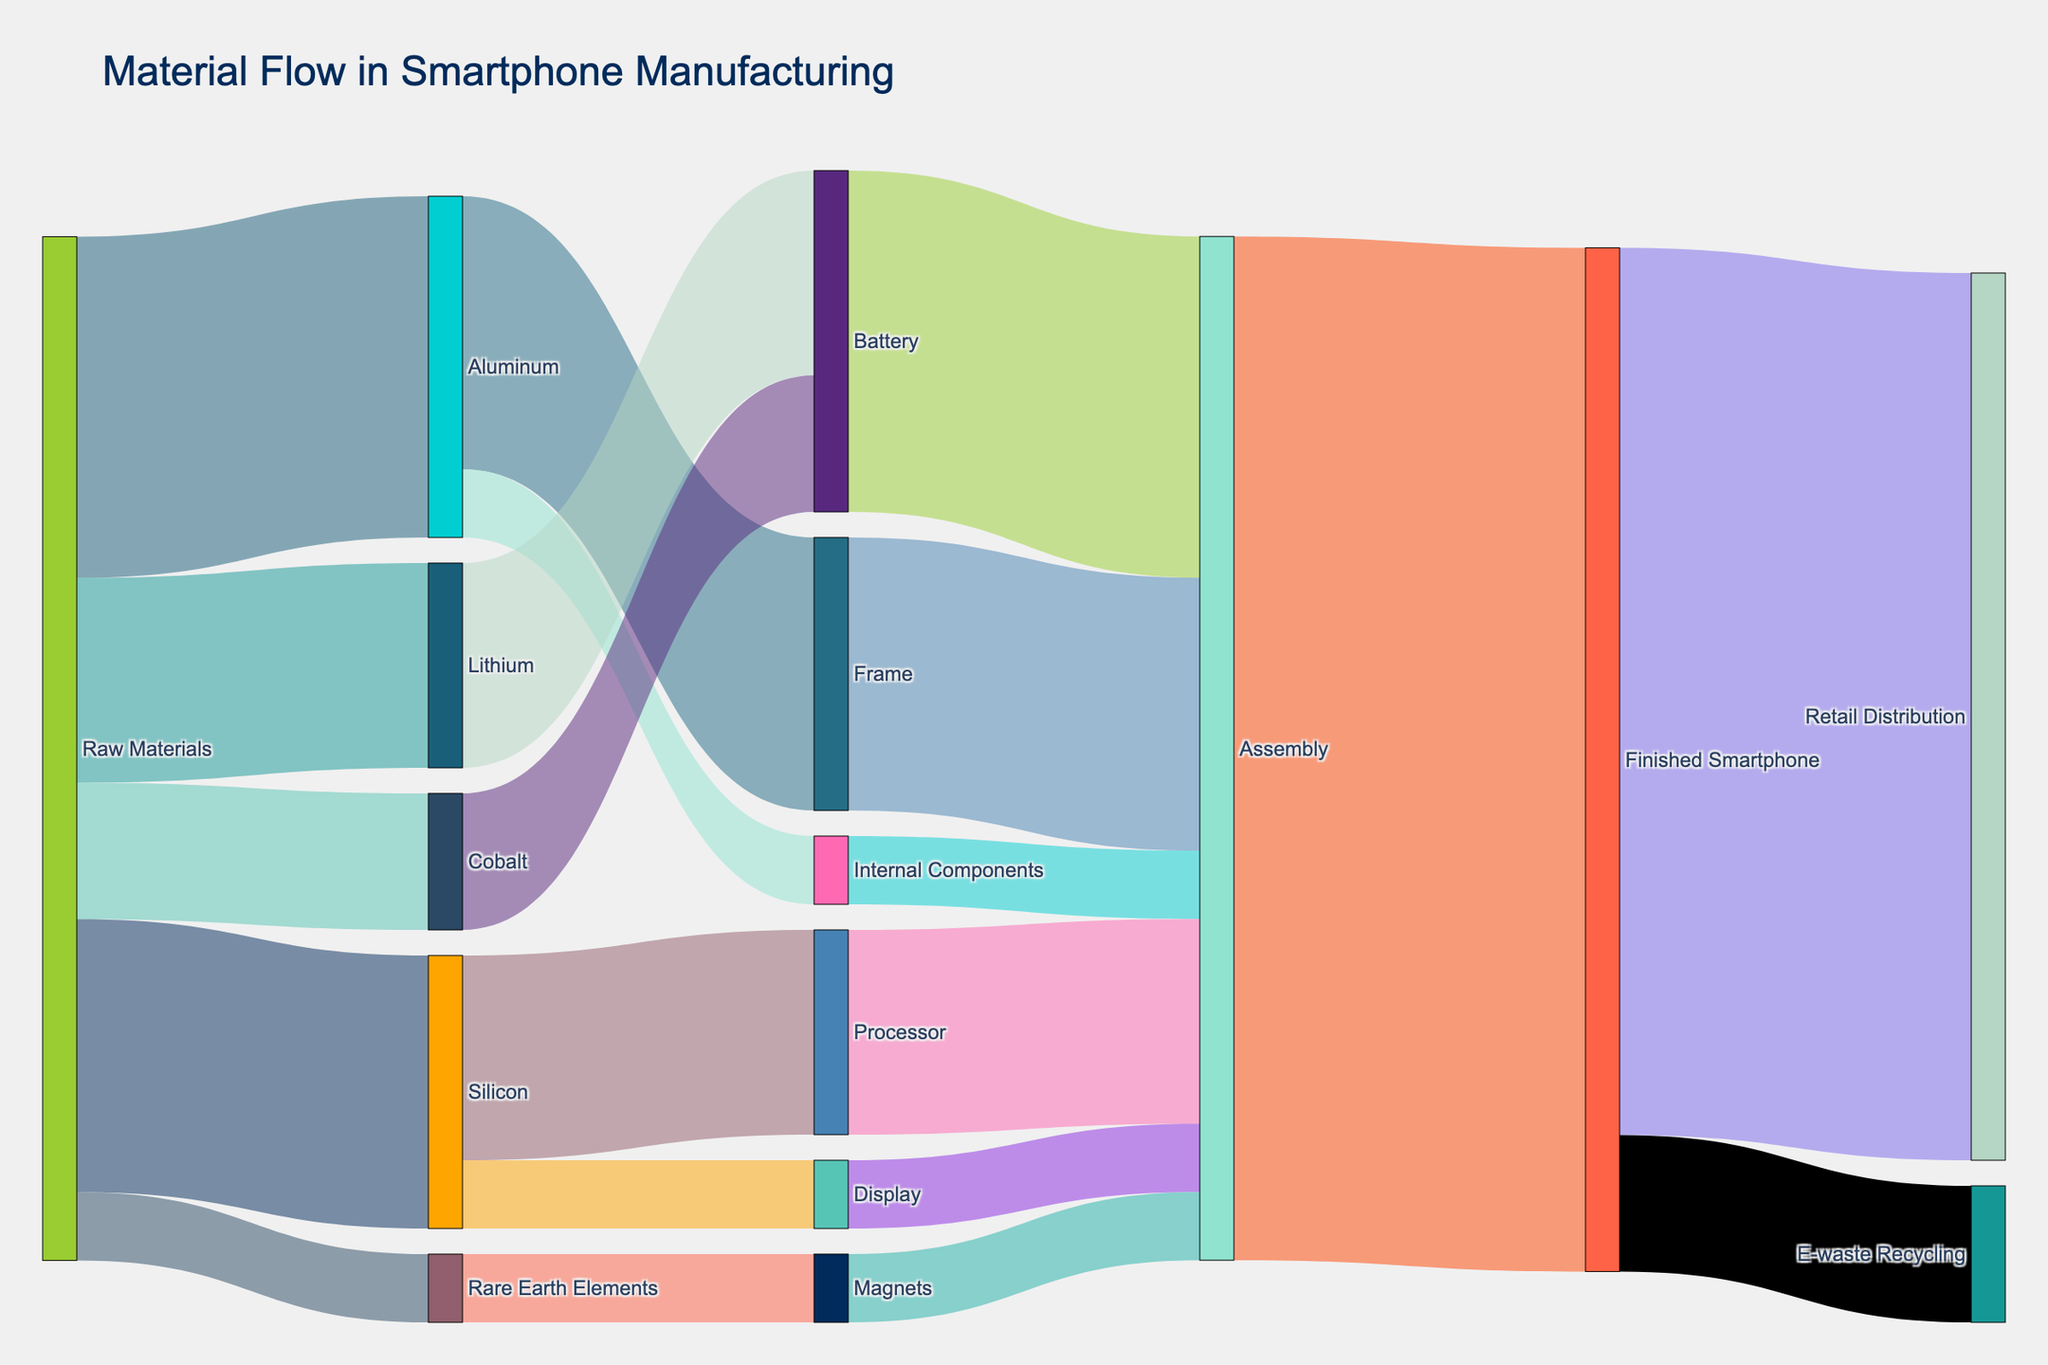What's the title of the figure? The title is typically displayed prominently at the top of the figure.
Answer: Material Flow in Smartphone Manufacturing Which material has the highest initial value by weight? The initial values are listed in the first set of flows originating from "Raw Materials". The values are: Aluminum (25), Lithium (15), Cobalt (10), Silicon (20), Rare Earth Elements (5). The highest value is 25 for Aluminum.
Answer: Aluminum How much Aluminum is used in both Frame and Internal Components? To find the total, look at the flows from Aluminum: 20 (Frame) + 5 (Internal Components). Total is 25.
Answer: 25 What is the final flow value that goes to Retail Distribution? Look at the flow going from Finished Smartphone to Retail Distribution; it shows 65.
Answer: 65 Which component has the most diverse sources of materials? To find this, look at the components which have incoming flows. Battery has flows from both Lithium (15) and Cobalt (10).
Answer: Battery Which single material entirely flows into a single component? Identify the flows where a material's total flow adds up to its contribution to a single component directly. For example, Lithium (15) entirely flows into Battery (15).
Answer: Lithium How many different materials contribute to the Assembly process? Look at the flows going into Assembly. They come from Frame, Internal Components, Battery, Processor, Display, and Magnets. That's 6 different materials contributing.
Answer: 6 What is the total weight of the finished smartphone before distribution or recycling? The total weight of the assembly that goes into the Finished Smartphone is 75, found by looking at the flow of Assembly to Finished Smartphone.
Answer: 75 Which material has the smallest contribution to a single target? Checking the values, the smallest single contribution is Rare Earth Elements to Magnets, valued at 5.
Answer: Rare Earth Elements What is the difference in value between raw materials (in total) and the finished smartphone weight? Sum of raw materials: Aluminum (25), Lithium (15), Cobalt (10), Silicon (20), Rare Earth Elements (5) = 75. Finished Smartphone weight is 75. The difference: 75 - 75 = 0.
Answer: 0 